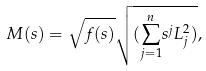Convert formula to latex. <formula><loc_0><loc_0><loc_500><loc_500>M ( s ) = \sqrt { f ( s ) } \sqrt { ( \overset { n } { \underset { j = 1 } { \sum } } s ^ { j } L _ { j } ^ { 2 } ) } ,</formula> 